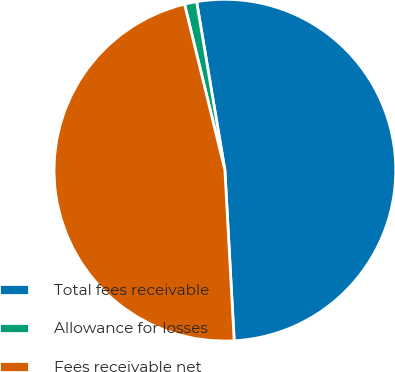Convert chart to OTSL. <chart><loc_0><loc_0><loc_500><loc_500><pie_chart><fcel>Total fees receivable<fcel>Allowance for losses<fcel>Fees receivable net<nl><fcel>51.78%<fcel>1.15%<fcel>47.07%<nl></chart> 